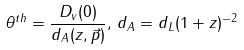Convert formula to latex. <formula><loc_0><loc_0><loc_500><loc_500>\theta ^ { t h } = \frac { D _ { v } ( 0 ) } { d _ { A } ( z , \vec { p } ) } , \, d _ { A } = d _ { L } ( 1 + z ) ^ { - 2 }</formula> 